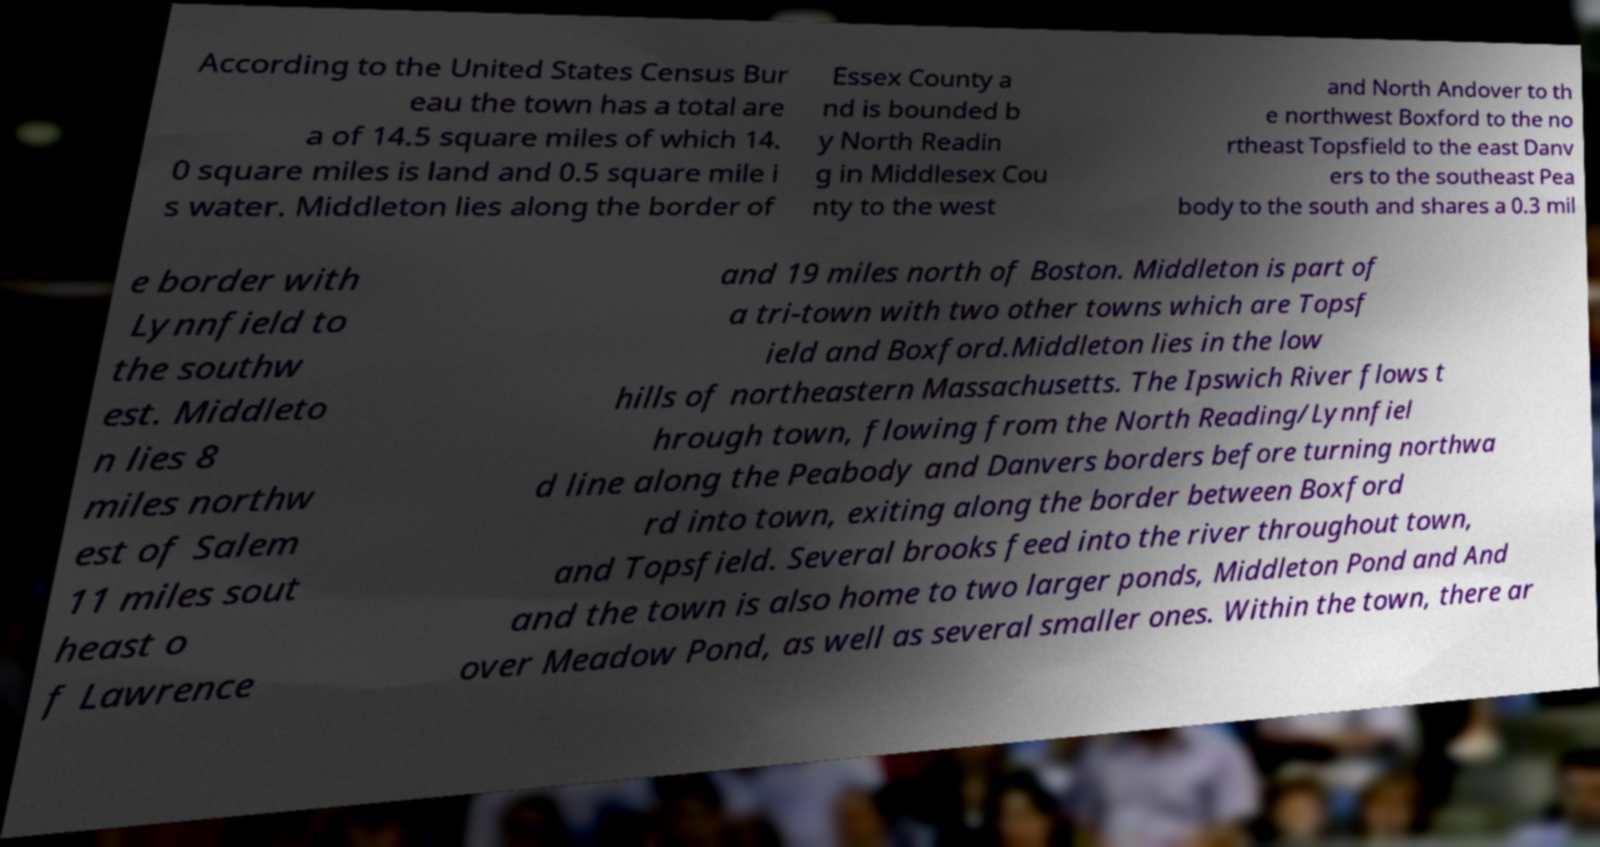Can you accurately transcribe the text from the provided image for me? According to the United States Census Bur eau the town has a total are a of 14.5 square miles of which 14. 0 square miles is land and 0.5 square mile i s water. Middleton lies along the border of Essex County a nd is bounded b y North Readin g in Middlesex Cou nty to the west and North Andover to th e northwest Boxford to the no rtheast Topsfield to the east Danv ers to the southeast Pea body to the south and shares a 0.3 mil e border with Lynnfield to the southw est. Middleto n lies 8 miles northw est of Salem 11 miles sout heast o f Lawrence and 19 miles north of Boston. Middleton is part of a tri-town with two other towns which are Topsf ield and Boxford.Middleton lies in the low hills of northeastern Massachusetts. The Ipswich River flows t hrough town, flowing from the North Reading/Lynnfiel d line along the Peabody and Danvers borders before turning northwa rd into town, exiting along the border between Boxford and Topsfield. Several brooks feed into the river throughout town, and the town is also home to two larger ponds, Middleton Pond and And over Meadow Pond, as well as several smaller ones. Within the town, there ar 